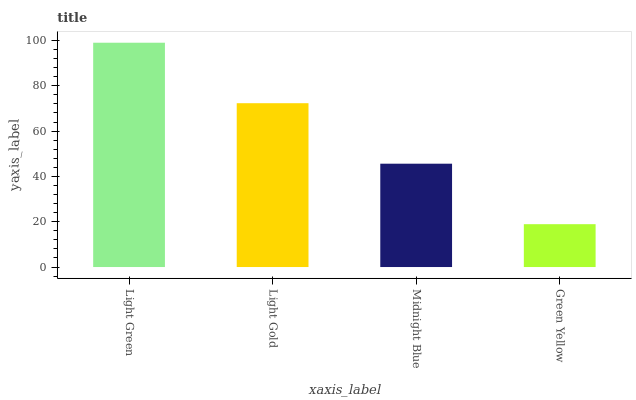Is Green Yellow the minimum?
Answer yes or no. Yes. Is Light Green the maximum?
Answer yes or no. Yes. Is Light Gold the minimum?
Answer yes or no. No. Is Light Gold the maximum?
Answer yes or no. No. Is Light Green greater than Light Gold?
Answer yes or no. Yes. Is Light Gold less than Light Green?
Answer yes or no. Yes. Is Light Gold greater than Light Green?
Answer yes or no. No. Is Light Green less than Light Gold?
Answer yes or no. No. Is Light Gold the high median?
Answer yes or no. Yes. Is Midnight Blue the low median?
Answer yes or no. Yes. Is Green Yellow the high median?
Answer yes or no. No. Is Light Green the low median?
Answer yes or no. No. 